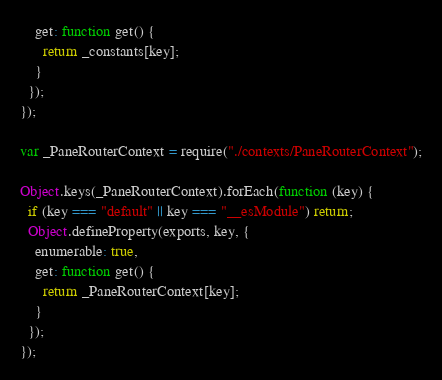Convert code to text. <code><loc_0><loc_0><loc_500><loc_500><_JavaScript_>    get: function get() {
      return _constants[key];
    }
  });
});

var _PaneRouterContext = require("./contexts/PaneRouterContext");

Object.keys(_PaneRouterContext).forEach(function (key) {
  if (key === "default" || key === "__esModule") return;
  Object.defineProperty(exports, key, {
    enumerable: true,
    get: function get() {
      return _PaneRouterContext[key];
    }
  });
});</code> 